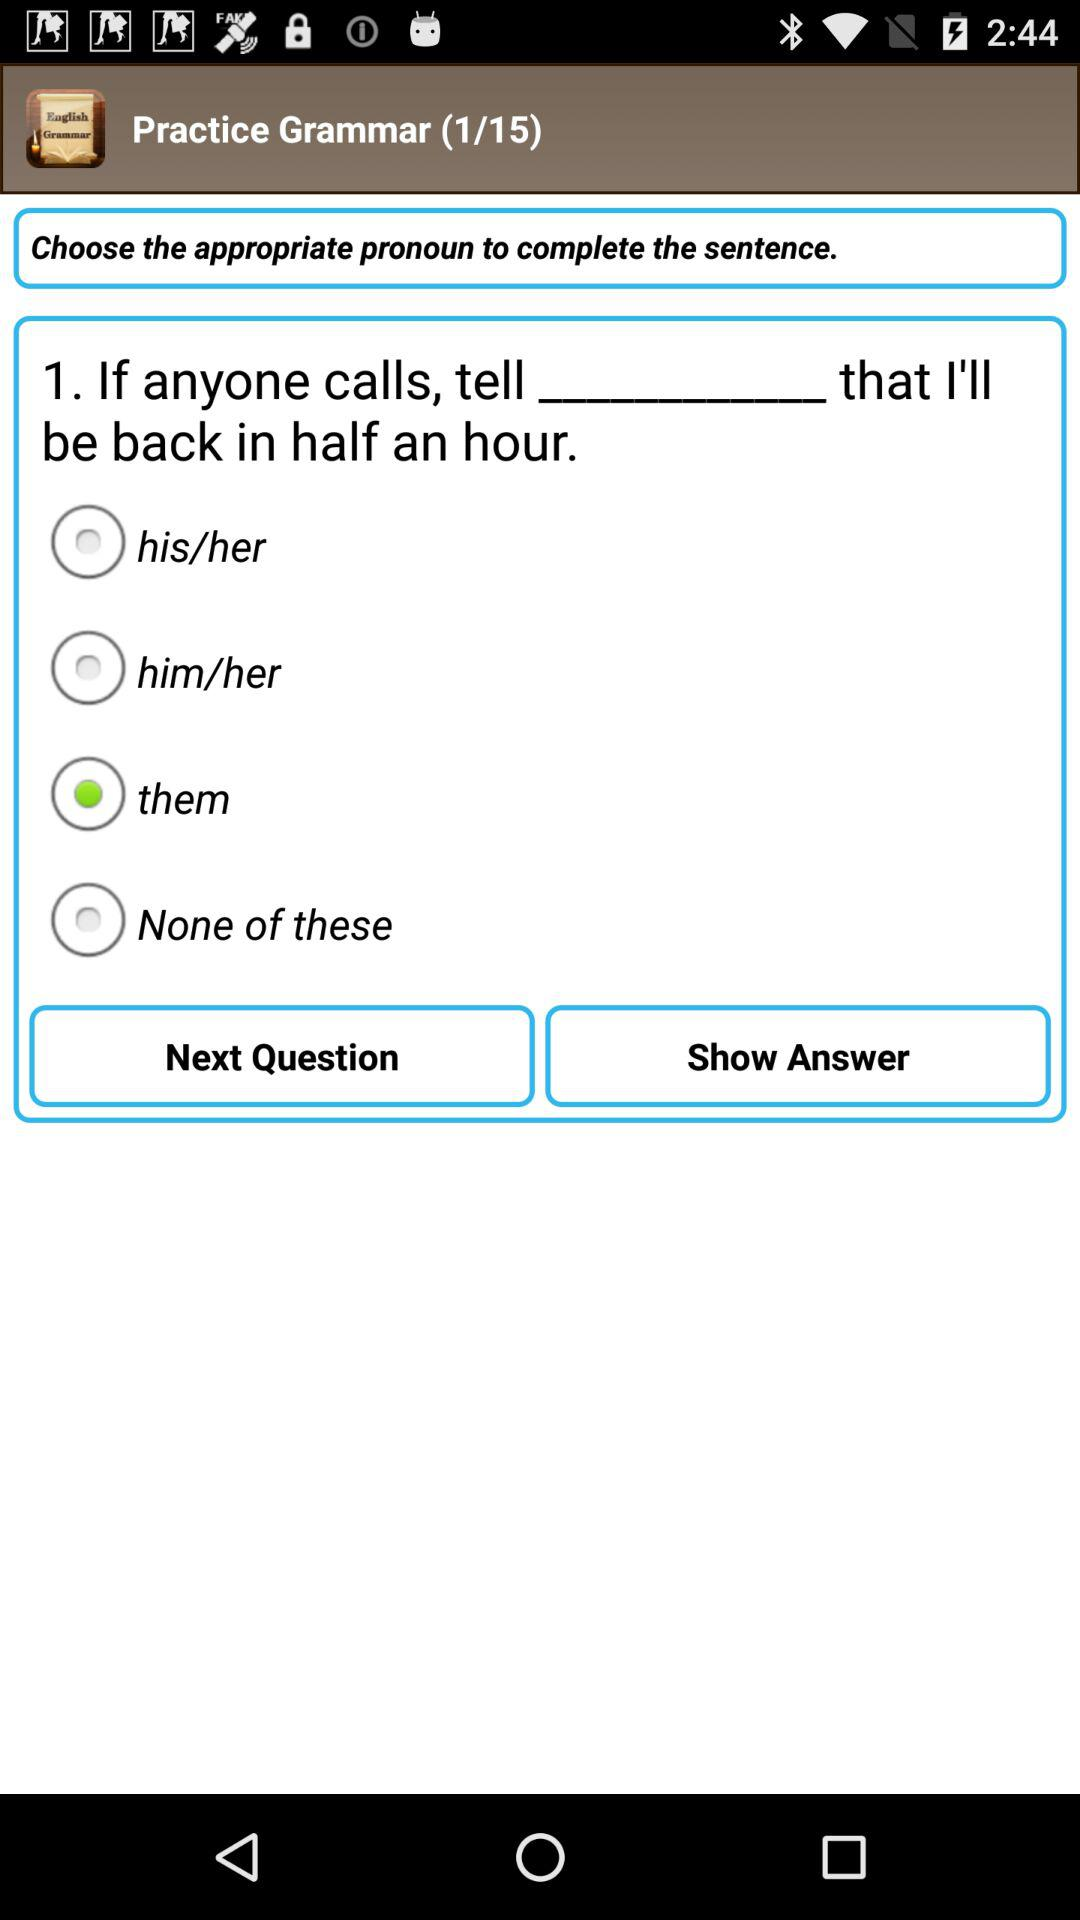Which option is not selected? The options that are not selected are "his/her", "him/her" and "None of these". 